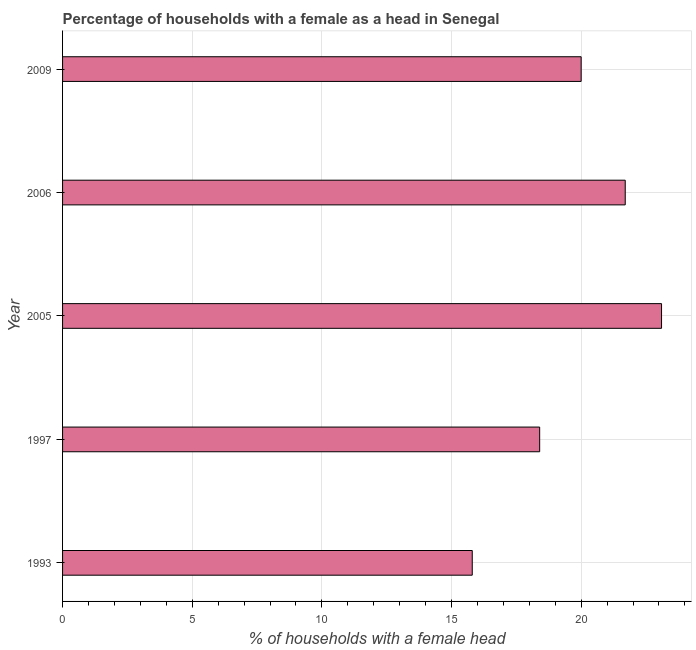Does the graph contain grids?
Your answer should be compact. Yes. What is the title of the graph?
Provide a succinct answer. Percentage of households with a female as a head in Senegal. What is the label or title of the X-axis?
Provide a succinct answer. % of households with a female head. What is the number of female supervised households in 1997?
Your answer should be compact. 18.4. Across all years, what is the maximum number of female supervised households?
Provide a succinct answer. 23.1. Across all years, what is the minimum number of female supervised households?
Your response must be concise. 15.8. What is the sum of the number of female supervised households?
Make the answer very short. 99. What is the average number of female supervised households per year?
Your answer should be compact. 19.8. What is the median number of female supervised households?
Provide a short and direct response. 20. What is the ratio of the number of female supervised households in 1997 to that in 2006?
Give a very brief answer. 0.85. Is the number of female supervised households in 1993 less than that in 2005?
Ensure brevity in your answer.  Yes. Is the sum of the number of female supervised households in 1993 and 2009 greater than the maximum number of female supervised households across all years?
Your response must be concise. Yes. Are all the bars in the graph horizontal?
Provide a succinct answer. Yes. What is the % of households with a female head of 1993?
Your response must be concise. 15.8. What is the % of households with a female head in 1997?
Keep it short and to the point. 18.4. What is the % of households with a female head of 2005?
Provide a short and direct response. 23.1. What is the % of households with a female head of 2006?
Provide a short and direct response. 21.7. What is the difference between the % of households with a female head in 1993 and 2009?
Provide a short and direct response. -4.2. What is the difference between the % of households with a female head in 1997 and 2009?
Your response must be concise. -1.6. What is the difference between the % of households with a female head in 2005 and 2009?
Keep it short and to the point. 3.1. What is the ratio of the % of households with a female head in 1993 to that in 1997?
Provide a succinct answer. 0.86. What is the ratio of the % of households with a female head in 1993 to that in 2005?
Your response must be concise. 0.68. What is the ratio of the % of households with a female head in 1993 to that in 2006?
Make the answer very short. 0.73. What is the ratio of the % of households with a female head in 1993 to that in 2009?
Offer a terse response. 0.79. What is the ratio of the % of households with a female head in 1997 to that in 2005?
Your answer should be very brief. 0.8. What is the ratio of the % of households with a female head in 1997 to that in 2006?
Your answer should be very brief. 0.85. What is the ratio of the % of households with a female head in 2005 to that in 2006?
Your response must be concise. 1.06. What is the ratio of the % of households with a female head in 2005 to that in 2009?
Give a very brief answer. 1.16. What is the ratio of the % of households with a female head in 2006 to that in 2009?
Make the answer very short. 1.08. 